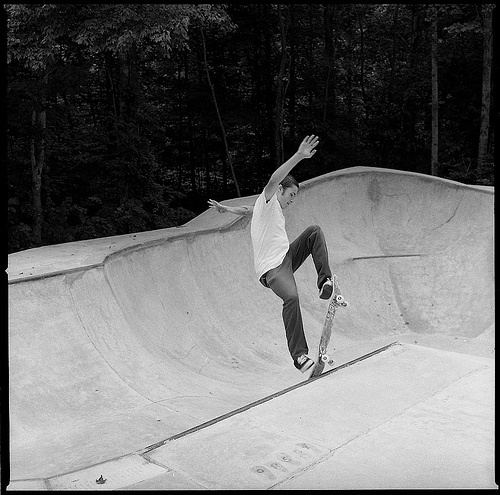Describe the objects in this image and their specific colors. I can see people in black, gray, darkgray, and lightgray tones and skateboard in black, darkgray, gray, and lightgray tones in this image. 